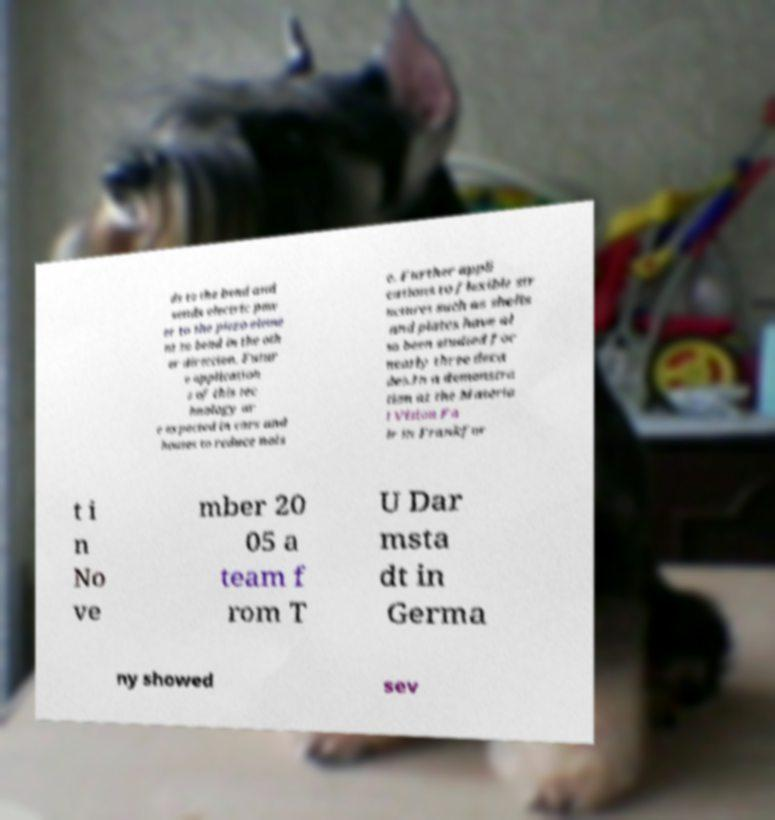Please read and relay the text visible in this image. What does it say? ds to the bend and sends electric pow er to the piezo eleme nt to bend in the oth er direction. Futur e application s of this tec hnology ar e expected in cars and houses to reduce nois e. Further appli cations to flexible str uctures such as shells and plates have al so been studied for nearly three deca des.In a demonstra tion at the Materia l Vision Fa ir in Frankfur t i n No ve mber 20 05 a team f rom T U Dar msta dt in Germa ny showed sev 